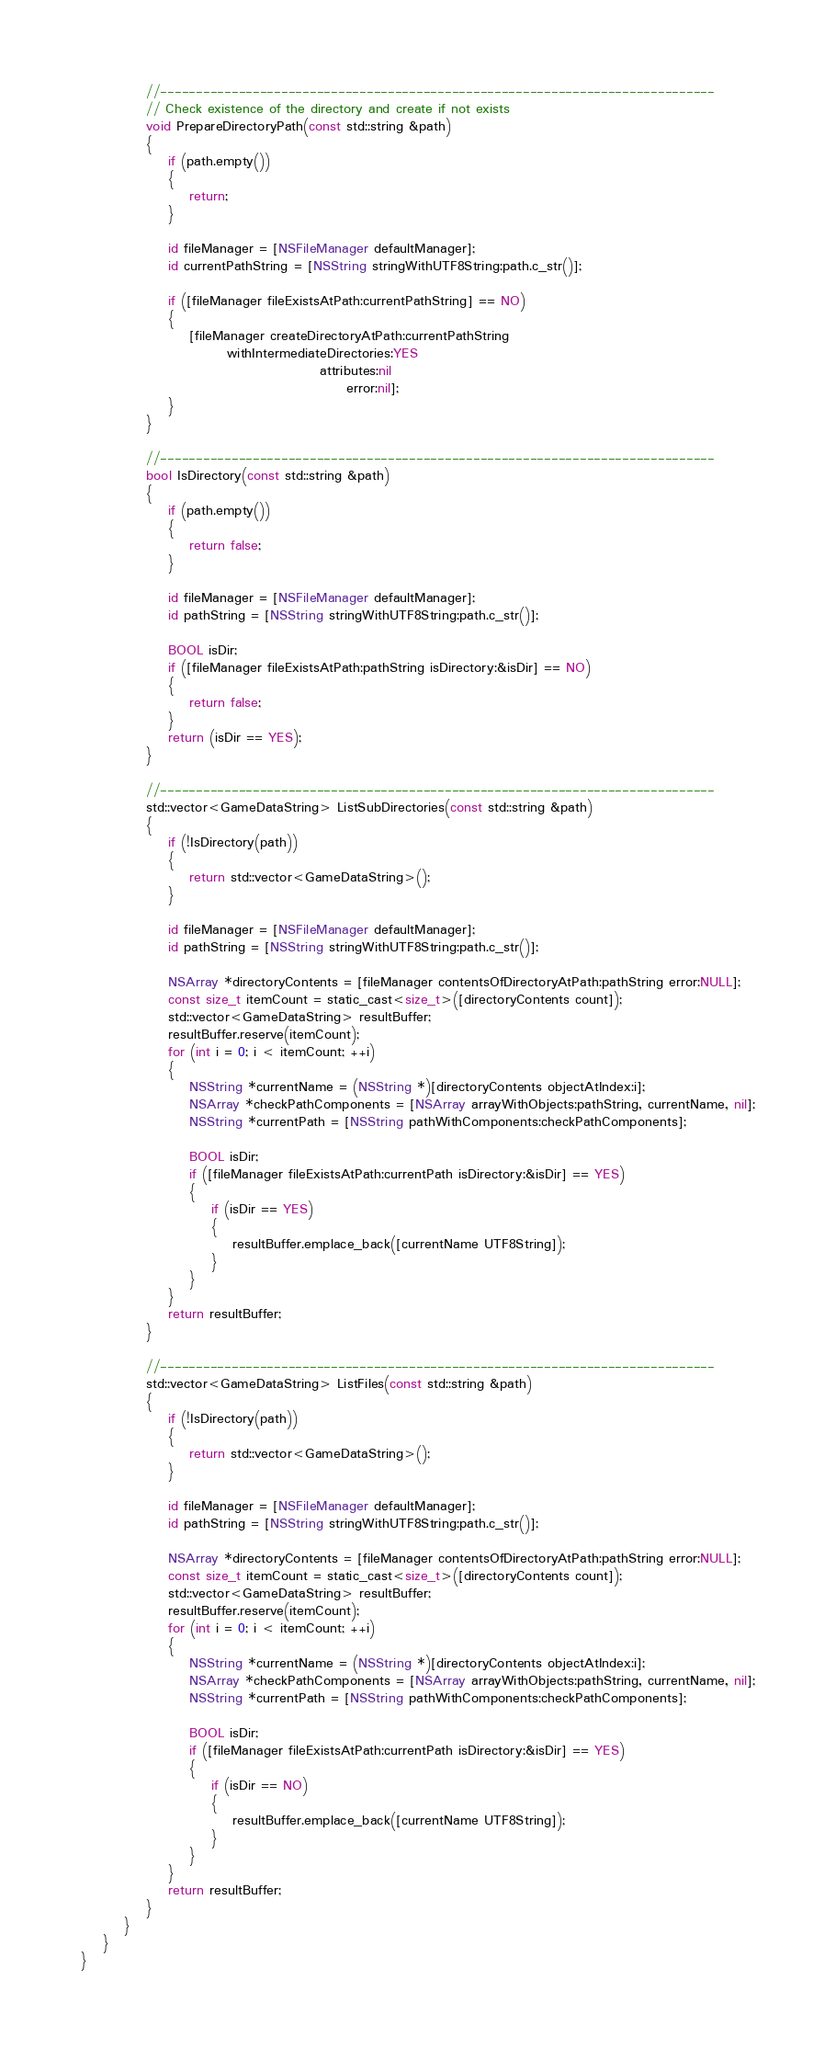Convert code to text. <code><loc_0><loc_0><loc_500><loc_500><_ObjectiveC_>
			//------------------------------------------------------------------------------
			// Check existence of the directory and create if not exists
			void PrepareDirectoryPath(const std::string &path)
			{
                if (path.empty())
                {
                    return;
                }
				
                id fileManager = [NSFileManager defaultManager];
                id currentPathString = [NSString stringWithUTF8String:path.c_str()];
                
                if ([fileManager fileExistsAtPath:currentPathString] == NO)
                {
                    [fileManager createDirectoryAtPath:currentPathString
                           withIntermediateDirectories:YES
                                            attributes:nil
                                                 error:nil];
                }
			}
			
			//------------------------------------------------------------------------------
			bool IsDirectory(const std::string &path)
			{
				if (path.empty())
                {
                    return false;
                }
				
                id fileManager = [NSFileManager defaultManager];
                id pathString = [NSString stringWithUTF8String:path.c_str()];
				
				BOOL isDir;
				if ([fileManager fileExistsAtPath:pathString isDirectory:&isDir] == NO)
                {
                    return false;
                }
				return (isDir == YES);
			}

			//------------------------------------------------------------------------------
			std::vector<GameDataString> ListSubDirectories(const std::string &path)
			{
				if (!IsDirectory(path))
				{
					return std::vector<GameDataString>();
				}
				
                id fileManager = [NSFileManager defaultManager];
				id pathString = [NSString stringWithUTF8String:path.c_str()];
				
				NSArray *directoryContents = [fileManager contentsOfDirectoryAtPath:pathString error:NULL];
				const size_t itemCount = static_cast<size_t>([directoryContents count]);
				std::vector<GameDataString> resultBuffer;
				resultBuffer.reserve(itemCount);
				for (int i = 0; i < itemCount; ++i)
				{
					NSString *currentName = (NSString *)[directoryContents objectAtIndex:i];
					NSArray *checkPathComponents = [NSArray arrayWithObjects:pathString, currentName, nil];
					NSString *currentPath = [NSString pathWithComponents:checkPathComponents];
					
					BOOL isDir;
					if ([fileManager fileExistsAtPath:currentPath isDirectory:&isDir] == YES)
					{
						if (isDir == YES)
						{
							resultBuffer.emplace_back([currentName UTF8String]);
						}
					}
				}
                return resultBuffer;
			}

			//------------------------------------------------------------------------------
			std::vector<GameDataString> ListFiles(const std::string &path)
			{
				if (!IsDirectory(path))
				{
					return std::vector<GameDataString>();
				}
				
                id fileManager = [NSFileManager defaultManager];
				id pathString = [NSString stringWithUTF8String:path.c_str()];
				
				NSArray *directoryContents = [fileManager contentsOfDirectoryAtPath:pathString error:NULL];
				const size_t itemCount = static_cast<size_t>([directoryContents count]);
				std::vector<GameDataString> resultBuffer;
				resultBuffer.reserve(itemCount);
				for (int i = 0; i < itemCount; ++i)
				{
					NSString *currentName = (NSString *)[directoryContents objectAtIndex:i];
					NSArray *checkPathComponents = [NSArray arrayWithObjects:pathString, currentName, nil];
					NSString *currentPath = [NSString pathWithComponents:checkPathComponents];
					
					BOOL isDir;
					if ([fileManager fileExistsAtPath:currentPath isDirectory:&isDir] == YES)
					{
						if (isDir == NO)
						{
							resultBuffer.emplace_back([currentName UTF8String]);
						}
					}
				}
                return resultBuffer;
			}
		}
	}
}
</code> 